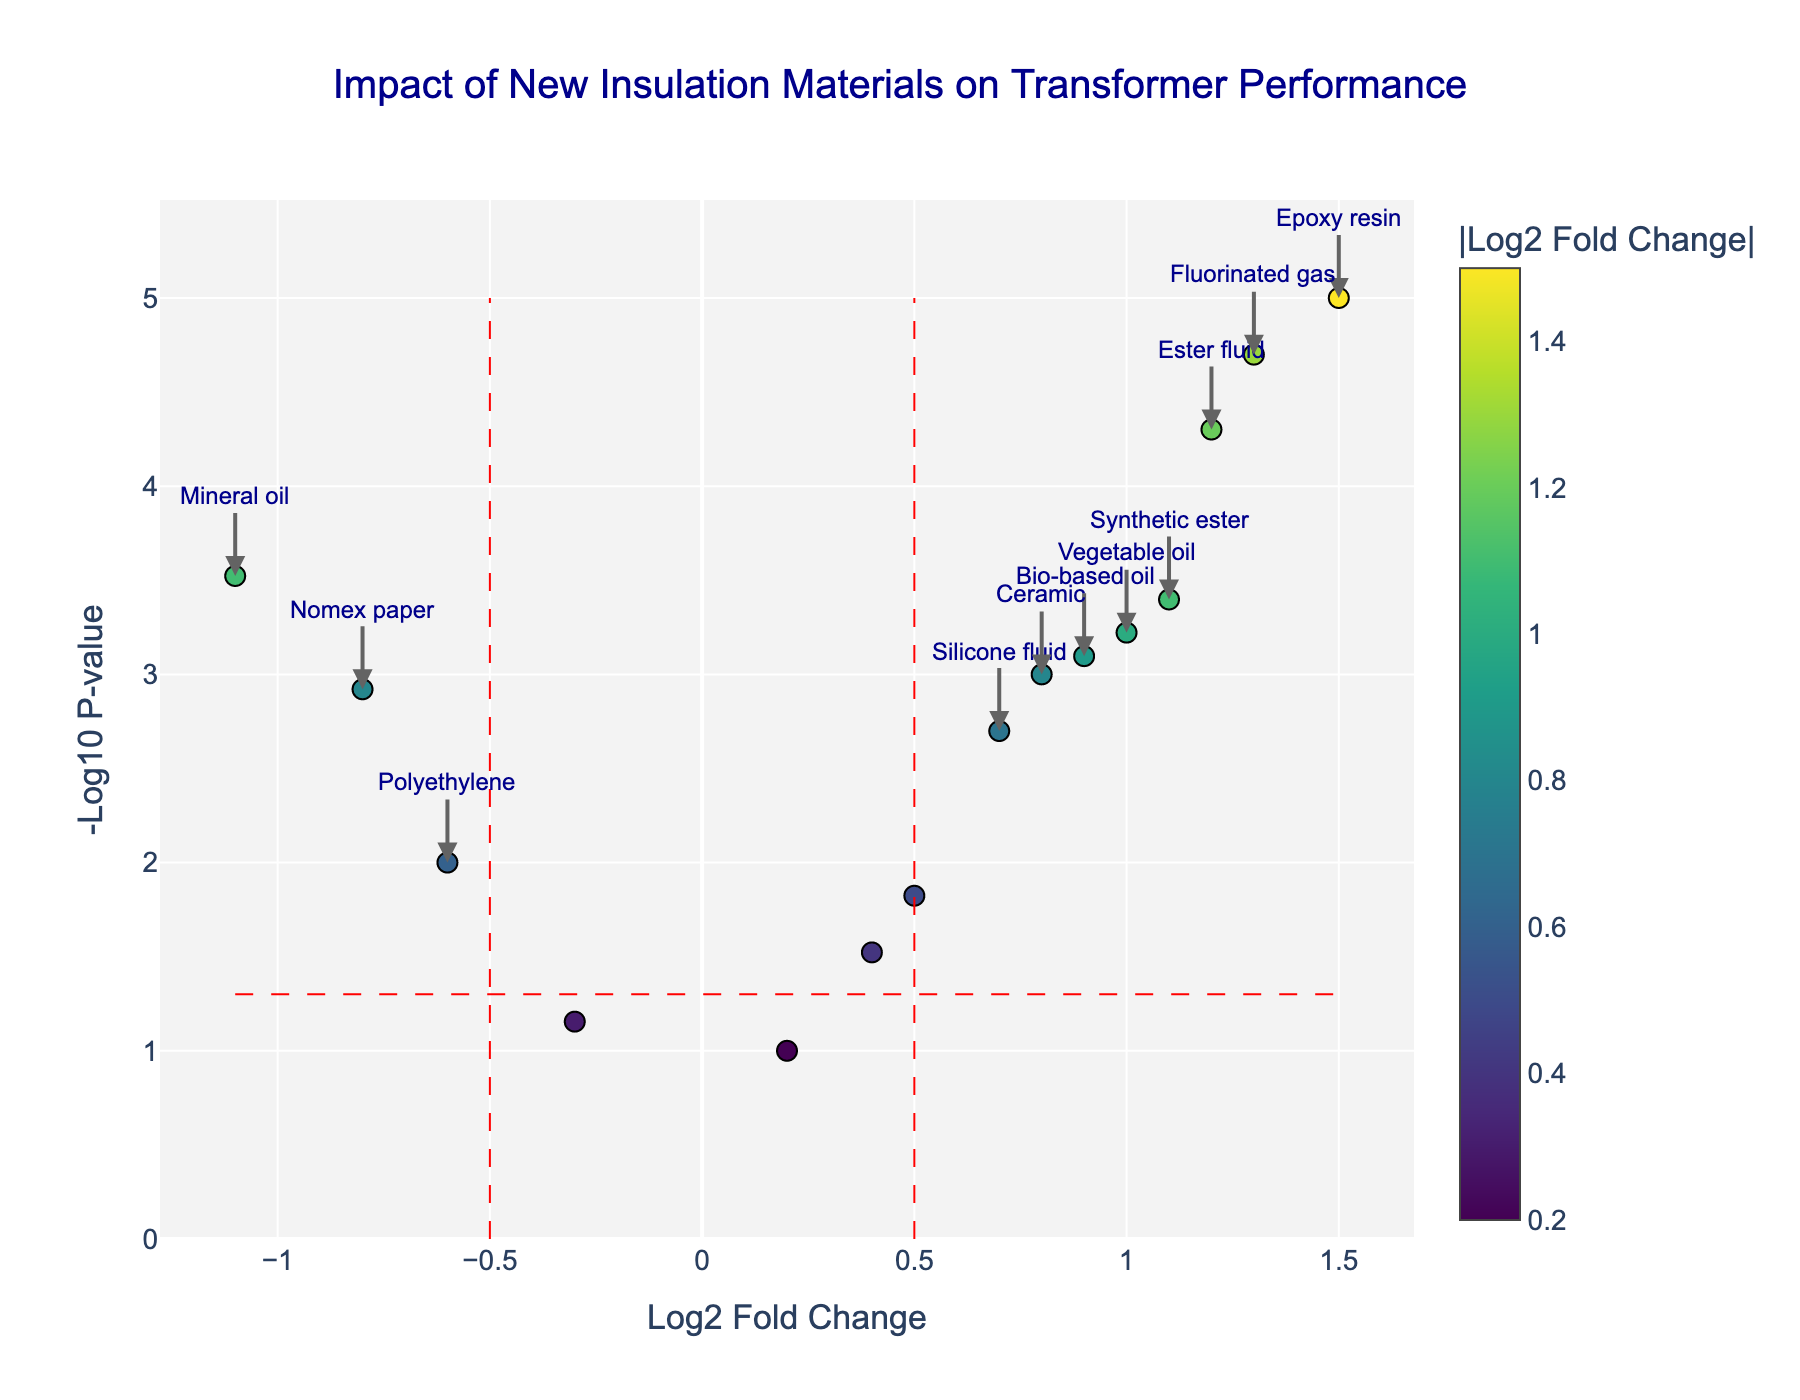What is the title of the plot? The title of the plot is usually placed at the top of the figure and it provides a brief description of the plot's content. In this case, it reads "Impact of New Insulation Materials on Transformer Performance."
Answer: Impact of New Insulation Materials on Transformer Performance How is the x-axis labeled? The x-axis represents the log2 fold change and it is labeled as "Log2 Fold Change." This helps to understand the degree of change in transformer performance due to the new insulation materials.
Answer: Log2 Fold Change Which material has the smallest p-value? To determine this, look for the data point with the highest -log10 p-value, as a lower p-value translates to a higher -log10 value. Here, Epoxy resin has the highest -log10 p-value.
Answer: Epoxy resin How many materials show a statistically significant increase in transformer performance? Materials with a log2 fold change greater than 0.5 and a -log10 p-value above the threshold line (corresponding to a p-value < 0.05) are considered significant. These include Ester fluid, Bio-based oil, Epoxy resin, Vegetable oil, Fluorinated gas, and Synthetic ester. Count these materials.
Answer: 6 Which material has the largest negative log2 fold change? To find the material with the largest negative log2 fold change, look for the point farthest to the left on the x-axis. Mineral oil has the smallest log2 fold change of -1.1.
Answer: Mineral oil How is the significance threshold for the log2 fold change denoted in the plot? The significance threshold for the log2 fold change is usually indicated by vertical dashed red lines that denote ±0.5 on the x-axis.
Answer: Vertical dashed red lines at ±0.5 Which materials have a statistically significant decrease in transformer performance? Look for materials with a log2 fold change less than -0.5 and a -log10 p-value above the threshold line. The materials are Nomex paper and Mineral oil.
Answer: Nomex paper and Mineral oil What is the log2 fold change and p-value for Bio-based oil? Hover over the point for Bio-based oil in the plot to see its log2 fold change and p-value. The hover text shows Log2 Fold Change: 0.9 and P-value: 0.0008.
Answer: Log2 Fold Change: 0.9, P-value: 0.0008 Are there any materials with a p-value greater than 0.05? Materials with a -log10 p-value below the horizontal dashed red line (p-value > 0.05) are Cellulose paper, Aramid fiber, Polyurethane, and Glass fiber.
Answer: Yes, 4 materials (Cellulose paper, Aramid fiber, Polyurethane, Glass fiber) How is the log2 fold change represented graphically in the plot? The log2 fold change is represented by the position on the x-axis. Materials with positive values show an increase in performance, while negative values indicate a decrease.
Answer: Position on the x-axis 